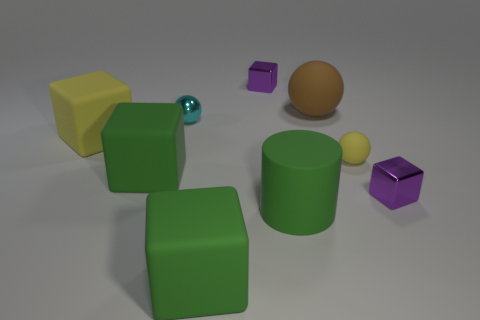Do the shiny block that is in front of the brown object and the green cube behind the big matte cylinder have the same size?
Provide a short and direct response. No. Does the rubber cylinder have the same size as the shiny sphere?
Give a very brief answer. No. The small block that is behind the yellow object left of the small purple object that is behind the brown rubber sphere is made of what material?
Give a very brief answer. Metal. Are there more large objects that are on the right side of the green cylinder than big blue cubes?
Make the answer very short. Yes. There is a cyan object that is the same size as the yellow matte sphere; what material is it?
Offer a very short reply. Metal. Are there any cyan rubber balls that have the same size as the brown sphere?
Offer a very short reply. No. There is a yellow object that is to the left of the green rubber cylinder; how big is it?
Provide a succinct answer. Large. What is the size of the brown matte object?
Ensure brevity in your answer.  Large. What number of blocks are big yellow rubber things or purple shiny things?
Offer a terse response. 3. There is a brown object that is the same material as the cylinder; what is its size?
Make the answer very short. Large. 